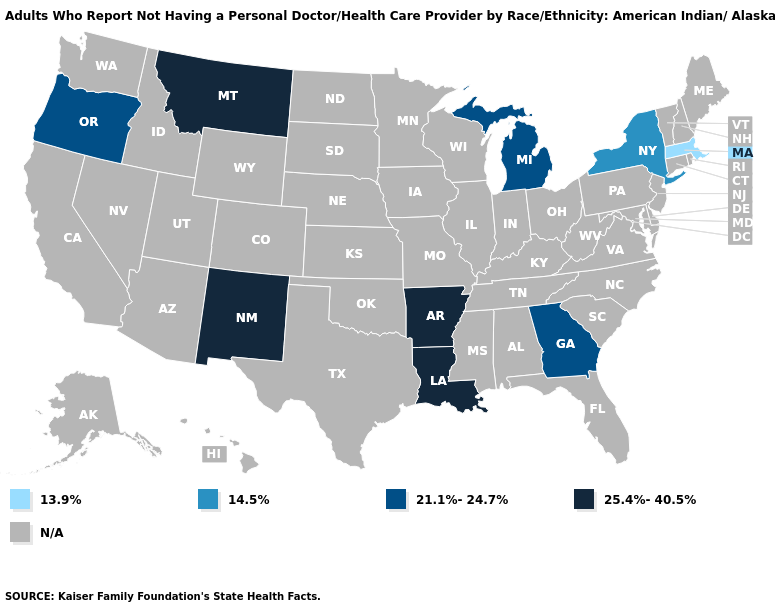Name the states that have a value in the range 21.1%-24.7%?
Be succinct. Georgia, Michigan, Oregon. Does Oregon have the lowest value in the West?
Be succinct. Yes. Does the first symbol in the legend represent the smallest category?
Short answer required. Yes. What is the lowest value in the Northeast?
Short answer required. 13.9%. Does Oregon have the lowest value in the West?
Concise answer only. Yes. What is the value of Wyoming?
Answer briefly. N/A. Does Arkansas have the highest value in the USA?
Answer briefly. Yes. What is the value of New Mexico?
Give a very brief answer. 25.4%-40.5%. Is the legend a continuous bar?
Concise answer only. No. Is the legend a continuous bar?
Give a very brief answer. No. 